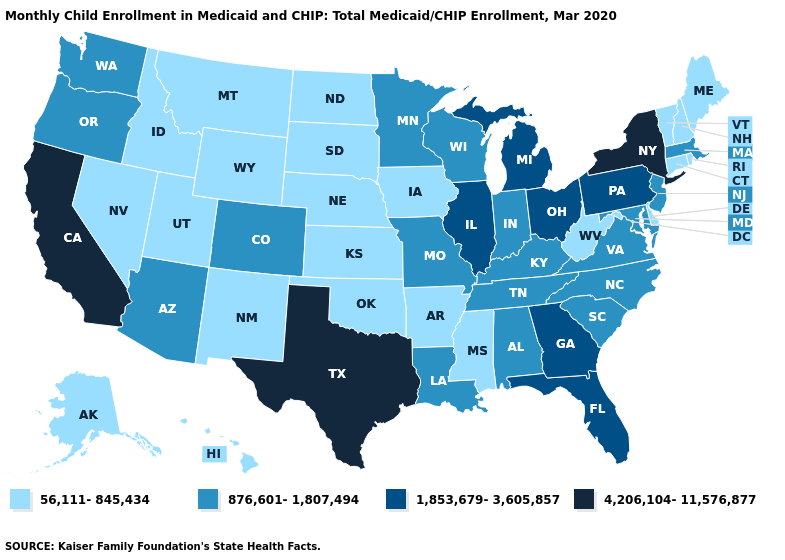What is the value of Oklahoma?
Keep it brief. 56,111-845,434. What is the value of Idaho?
Answer briefly. 56,111-845,434. What is the highest value in states that border Massachusetts?
Answer briefly. 4,206,104-11,576,877. What is the value of New Mexico?
Be succinct. 56,111-845,434. Does the map have missing data?
Quick response, please. No. Which states have the lowest value in the South?
Be succinct. Arkansas, Delaware, Mississippi, Oklahoma, West Virginia. What is the lowest value in the West?
Be succinct. 56,111-845,434. Among the states that border South Carolina , does Georgia have the highest value?
Concise answer only. Yes. Which states hav the highest value in the Northeast?
Short answer required. New York. Name the states that have a value in the range 1,853,679-3,605,857?
Give a very brief answer. Florida, Georgia, Illinois, Michigan, Ohio, Pennsylvania. Does Alabama have a higher value than Iowa?
Be succinct. Yes. How many symbols are there in the legend?
Quick response, please. 4. Name the states that have a value in the range 1,853,679-3,605,857?
Give a very brief answer. Florida, Georgia, Illinois, Michigan, Ohio, Pennsylvania. What is the value of Arizona?
Quick response, please. 876,601-1,807,494. Which states have the lowest value in the South?
Write a very short answer. Arkansas, Delaware, Mississippi, Oklahoma, West Virginia. 